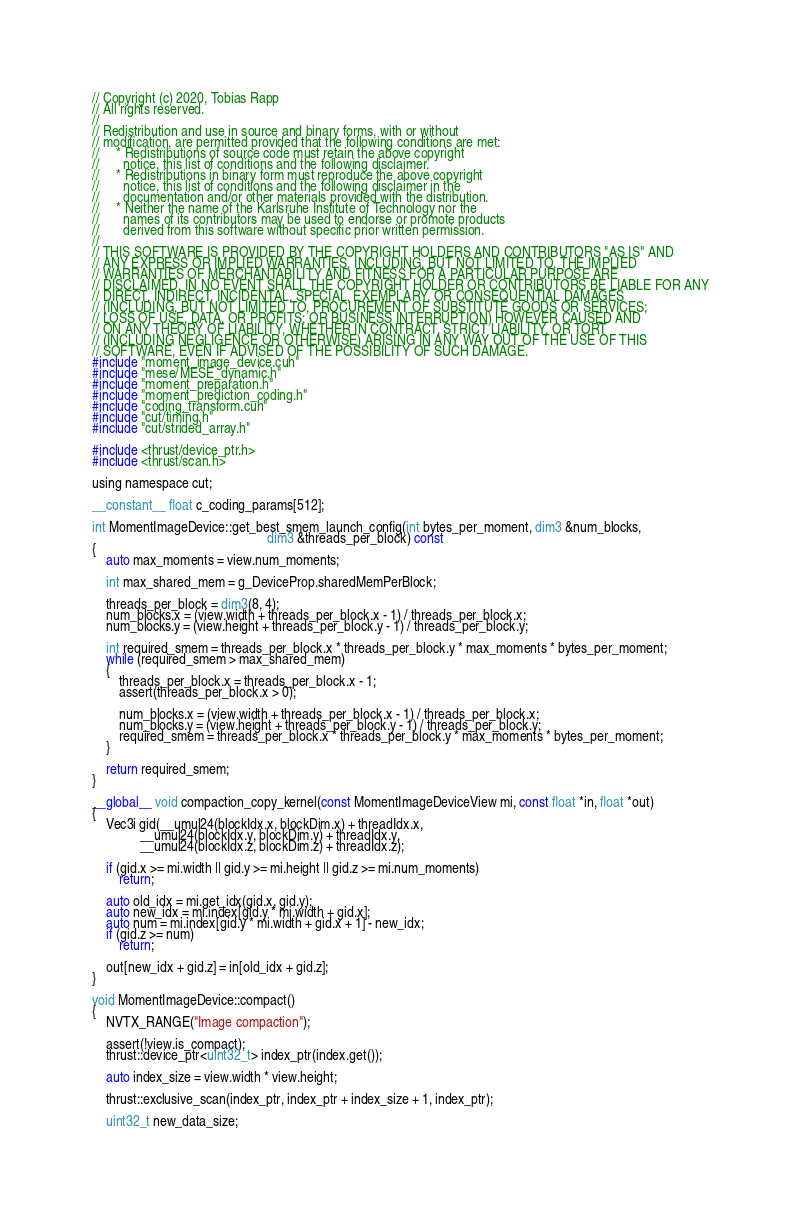<code> <loc_0><loc_0><loc_500><loc_500><_Cuda_>// Copyright (c) 2020, Tobias Rapp
// All rights reserved.
//
// Redistribution and use in source and binary forms, with or without
// modification, are permitted provided that the following conditions are met:
//     * Redistributions of source code must retain the above copyright
//       notice, this list of conditions and the following disclaimer.
//     * Redistributions in binary form must reproduce the above copyright
//       notice, this list of conditions and the following disclaimer in the
//       documentation and/or other materials provided with the distribution.
//     * Neither the name of the Karlsruhe Institute of Technology nor the
//       names of its contributors may be used to endorse or promote products
//       derived from this software without specific prior written permission.
//
// THIS SOFTWARE IS PROVIDED BY THE COPYRIGHT HOLDERS AND CONTRIBUTORS "AS IS" AND
// ANY EXPRESS OR IMPLIED WARRANTIES, INCLUDING, BUT NOT LIMITED TO, THE IMPLIED
// WARRANTIES OF MERCHANTABILITY AND FITNESS FOR A PARTICULAR PURPOSE ARE
// DISCLAIMED. IN NO EVENT SHALL THE COPYRIGHT HOLDER OR CONTRIBUTORS BE LIABLE FOR ANY
// DIRECT, INDIRECT, INCIDENTAL, SPECIAL, EXEMPLARY, OR CONSEQUENTIAL DAMAGES
// (INCLUDING, BUT NOT LIMITED TO, PROCUREMENT OF SUBSTITUTE GOODS OR SERVICES;
// LOSS OF USE, DATA, OR PROFITS; OR BUSINESS INTERRUPTION) HOWEVER CAUSED AND
// ON ANY THEORY OF LIABILITY, WHETHER IN CONTRACT, STRICT LIABILITY, OR TORT
// (INCLUDING NEGLIGENCE OR OTHERWISE) ARISING IN ANY WAY OUT OF THE USE OF THIS
// SOFTWARE, EVEN IF ADVISED OF THE POSSIBILITY OF SUCH DAMAGE.
#include "moment_image_device.cuh"
#include "mese/MESE_dynamic.h"
#include "moment_preparation.h"
#include "moment_prediction_coding.h"
#include "coding_transform.cuh"
#include "cut/timing.h"
#include "cut/strided_array.h"

#include <thrust/device_ptr.h>
#include <thrust/scan.h>

using namespace cut;

__constant__ float c_coding_params[512];

int MomentImageDevice::get_best_smem_launch_config(int bytes_per_moment, dim3 &num_blocks,
                                                   dim3 &threads_per_block) const
{
    auto max_moments = view.num_moments;

    int max_shared_mem = g_DeviceProp.sharedMemPerBlock;

    threads_per_block = dim3(8, 4);
    num_blocks.x = (view.width + threads_per_block.x - 1) / threads_per_block.x;
    num_blocks.y = (view.height + threads_per_block.y - 1) / threads_per_block.y;

    int required_smem = threads_per_block.x * threads_per_block.y * max_moments * bytes_per_moment;
    while (required_smem > max_shared_mem)
    {
        threads_per_block.x = threads_per_block.x - 1;
        assert(threads_per_block.x > 0);

        num_blocks.x = (view.width + threads_per_block.x - 1) / threads_per_block.x;
        num_blocks.y = (view.height + threads_per_block.y - 1) / threads_per_block.y;
        required_smem = threads_per_block.x * threads_per_block.y * max_moments * bytes_per_moment;
    }

    return required_smem;
}

__global__ void compaction_copy_kernel(const MomentImageDeviceView mi, const float *in, float *out)
{
    Vec3i gid(__umul24(blockIdx.x, blockDim.x) + threadIdx.x,
              __umul24(blockIdx.y, blockDim.y) + threadIdx.y,
              __umul24(blockIdx.z, blockDim.z) + threadIdx.z);

    if (gid.x >= mi.width || gid.y >= mi.height || gid.z >= mi.num_moments)
        return;

    auto old_idx = mi.get_idx(gid.x, gid.y);
    auto new_idx = mi.index[gid.y * mi.width + gid.x];
    auto num = mi.index[gid.y * mi.width + gid.x + 1] - new_idx;
    if (gid.z >= num)
        return;

    out[new_idx + gid.z] = in[old_idx + gid.z];
}

void MomentImageDevice::compact()
{
    NVTX_RANGE("Image compaction");

    assert(!view.is_compact);
    thrust::device_ptr<uint32_t> index_ptr(index.get());

    auto index_size = view.width * view.height;

    thrust::exclusive_scan(index_ptr, index_ptr + index_size + 1, index_ptr);

    uint32_t new_data_size;</code> 